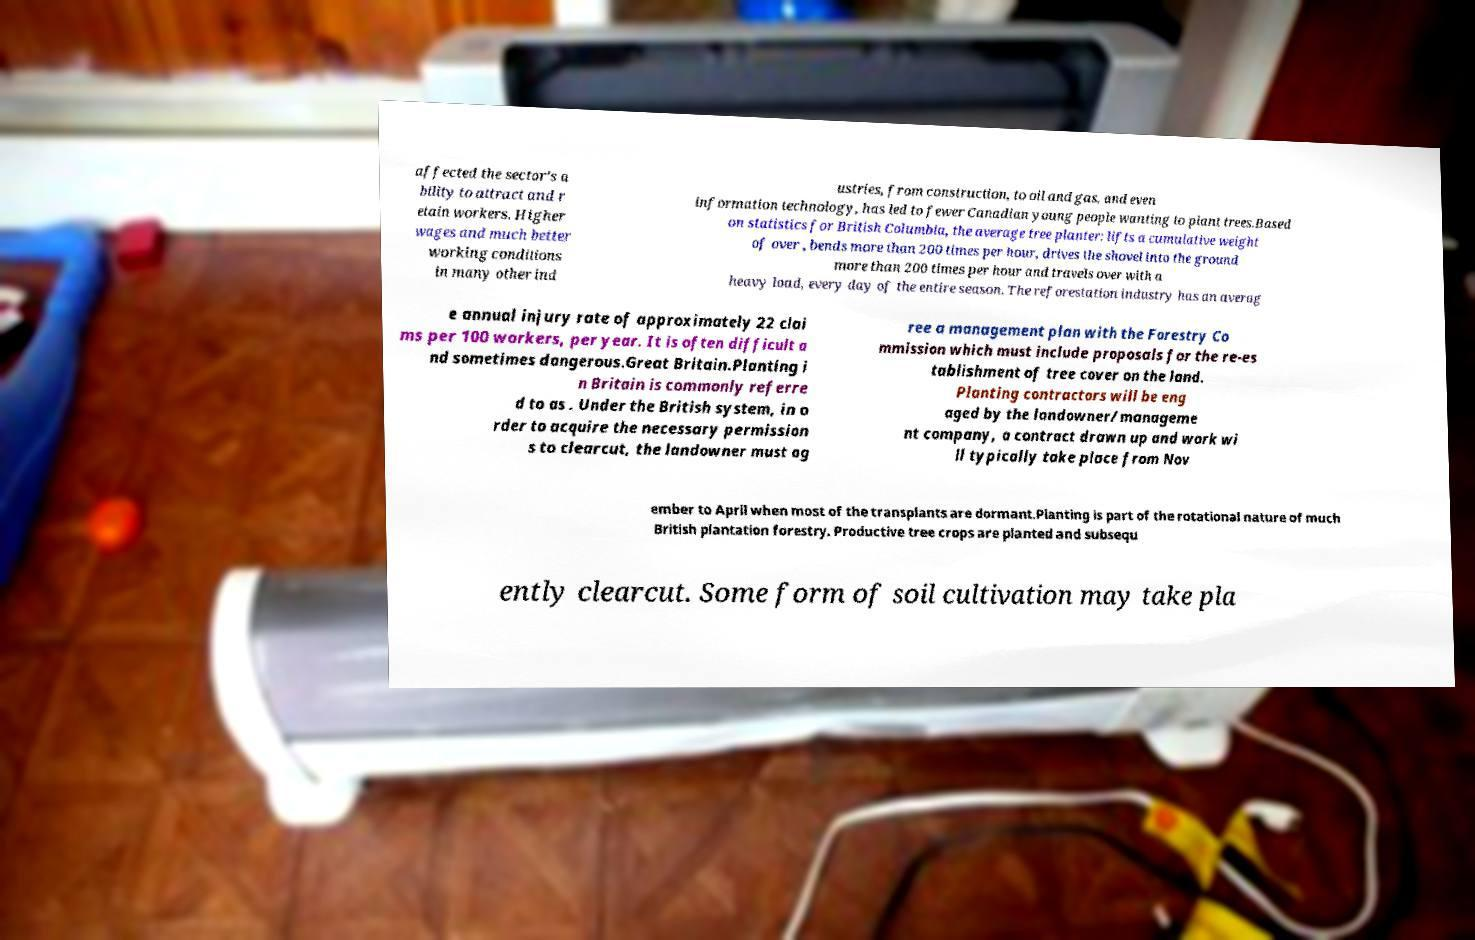Can you accurately transcribe the text from the provided image for me? affected the sector's a bility to attract and r etain workers. Higher wages and much better working conditions in many other ind ustries, from construction, to oil and gas, and even information technology, has led to fewer Canadian young people wanting to plant trees.Based on statistics for British Columbia, the average tree planter: lifts a cumulative weight of over , bends more than 200 times per hour, drives the shovel into the ground more than 200 times per hour and travels over with a heavy load, every day of the entire season. The reforestation industry has an averag e annual injury rate of approximately 22 clai ms per 100 workers, per year. It is often difficult a nd sometimes dangerous.Great Britain.Planting i n Britain is commonly referre d to as . Under the British system, in o rder to acquire the necessary permission s to clearcut, the landowner must ag ree a management plan with the Forestry Co mmission which must include proposals for the re-es tablishment of tree cover on the land. Planting contractors will be eng aged by the landowner/manageme nt company, a contract drawn up and work wi ll typically take place from Nov ember to April when most of the transplants are dormant.Planting is part of the rotational nature of much British plantation forestry. Productive tree crops are planted and subsequ ently clearcut. Some form of soil cultivation may take pla 